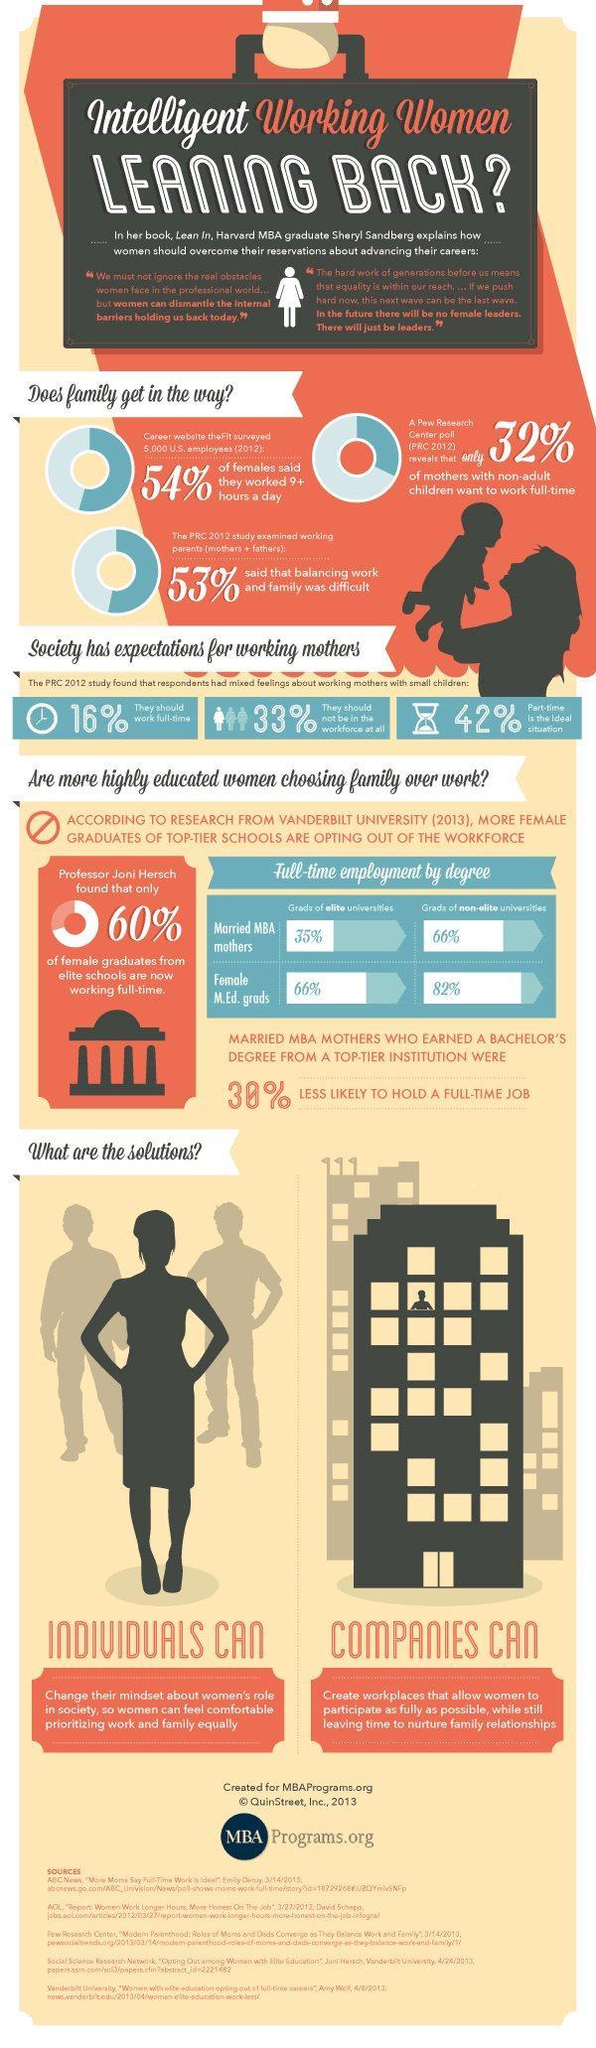What percentage of female graduates from elite schools are not now working full-time?
Answer the question with a short phrase. 40% What percentage of mothers with non-adult children don't want to work full-time? 68% 